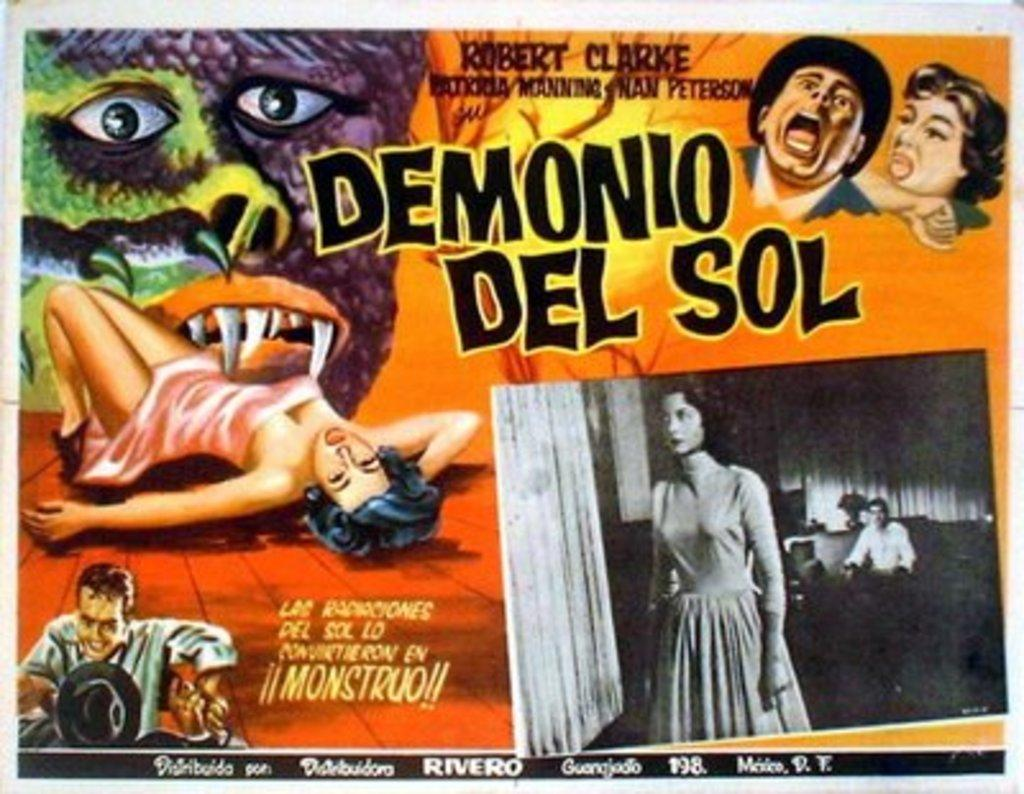<image>
Render a clear and concise summary of the photo. The movie poster for Demonio del Sol has a creature with fangs biting a woman. 